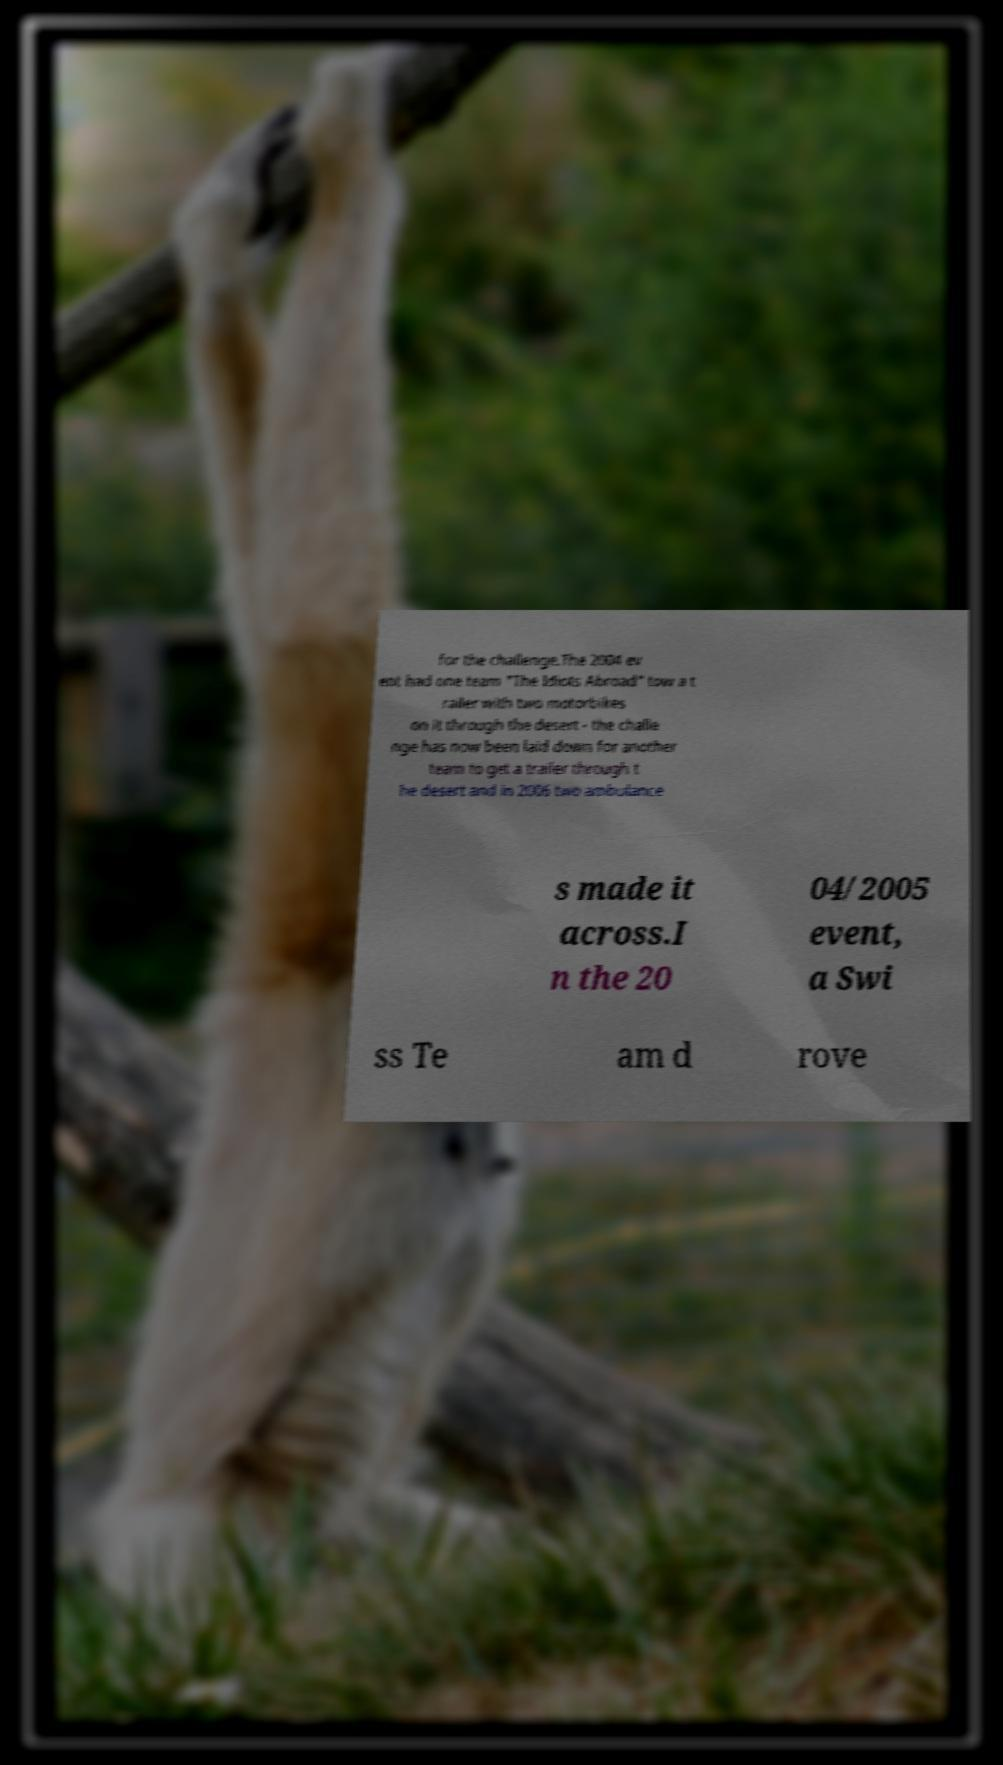Can you accurately transcribe the text from the provided image for me? for the challenge.The 2004 ev ent had one team "The Idiots Abroad" tow a t railer with two motorbikes on it through the desert - the challe nge has now been laid down for another team to get a trailer through t he desert and in 2006 two ambulance s made it across.I n the 20 04/2005 event, a Swi ss Te am d rove 